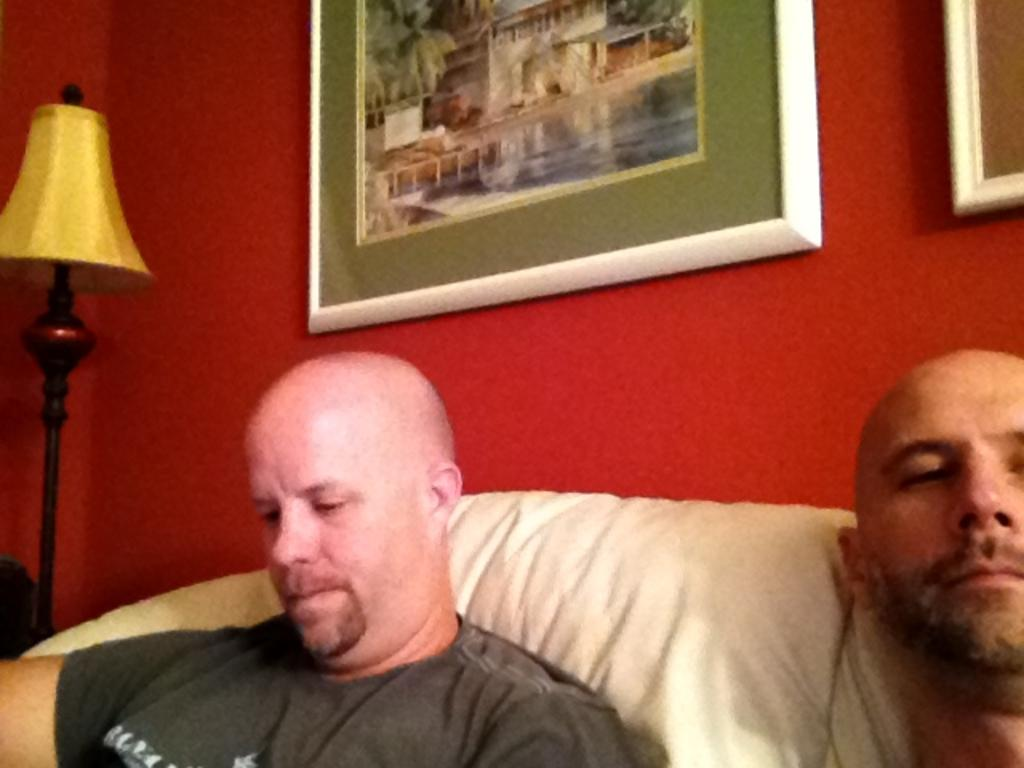What are the two men in the foreground of the image doing? The two men are sitting on the sofa in the foreground. What can be seen on the red wall in the background? There are two frames on the red wall in the background. What object is located on the left side of the image? There is a lamp on the left side of the image. How many potatoes are visible in the image? There are no potatoes present in the image. What type of oil is being used in the lamp in the image? The image does not provide information about the type of oil used in the lamp, as it only shows the lamp itself. 